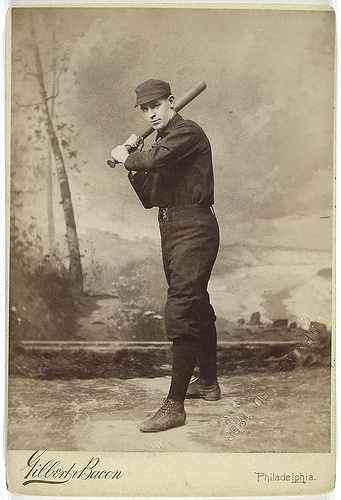Describe the objects in this image and their specific colors. I can see people in white, black, gray, and maroon tones and baseball bat in white, tan, and gray tones in this image. 